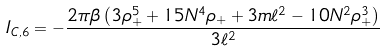<formula> <loc_0><loc_0><loc_500><loc_500>I _ { C , 6 } = - \frac { 2 \pi \beta \left ( 3 \rho _ { + } ^ { 5 } + 1 5 N ^ { 4 } \rho _ { + } + 3 m \ell ^ { 2 } - 1 0 N ^ { 2 } \rho _ { + } ^ { 3 } \right ) } { 3 \ell ^ { 2 } }</formula> 